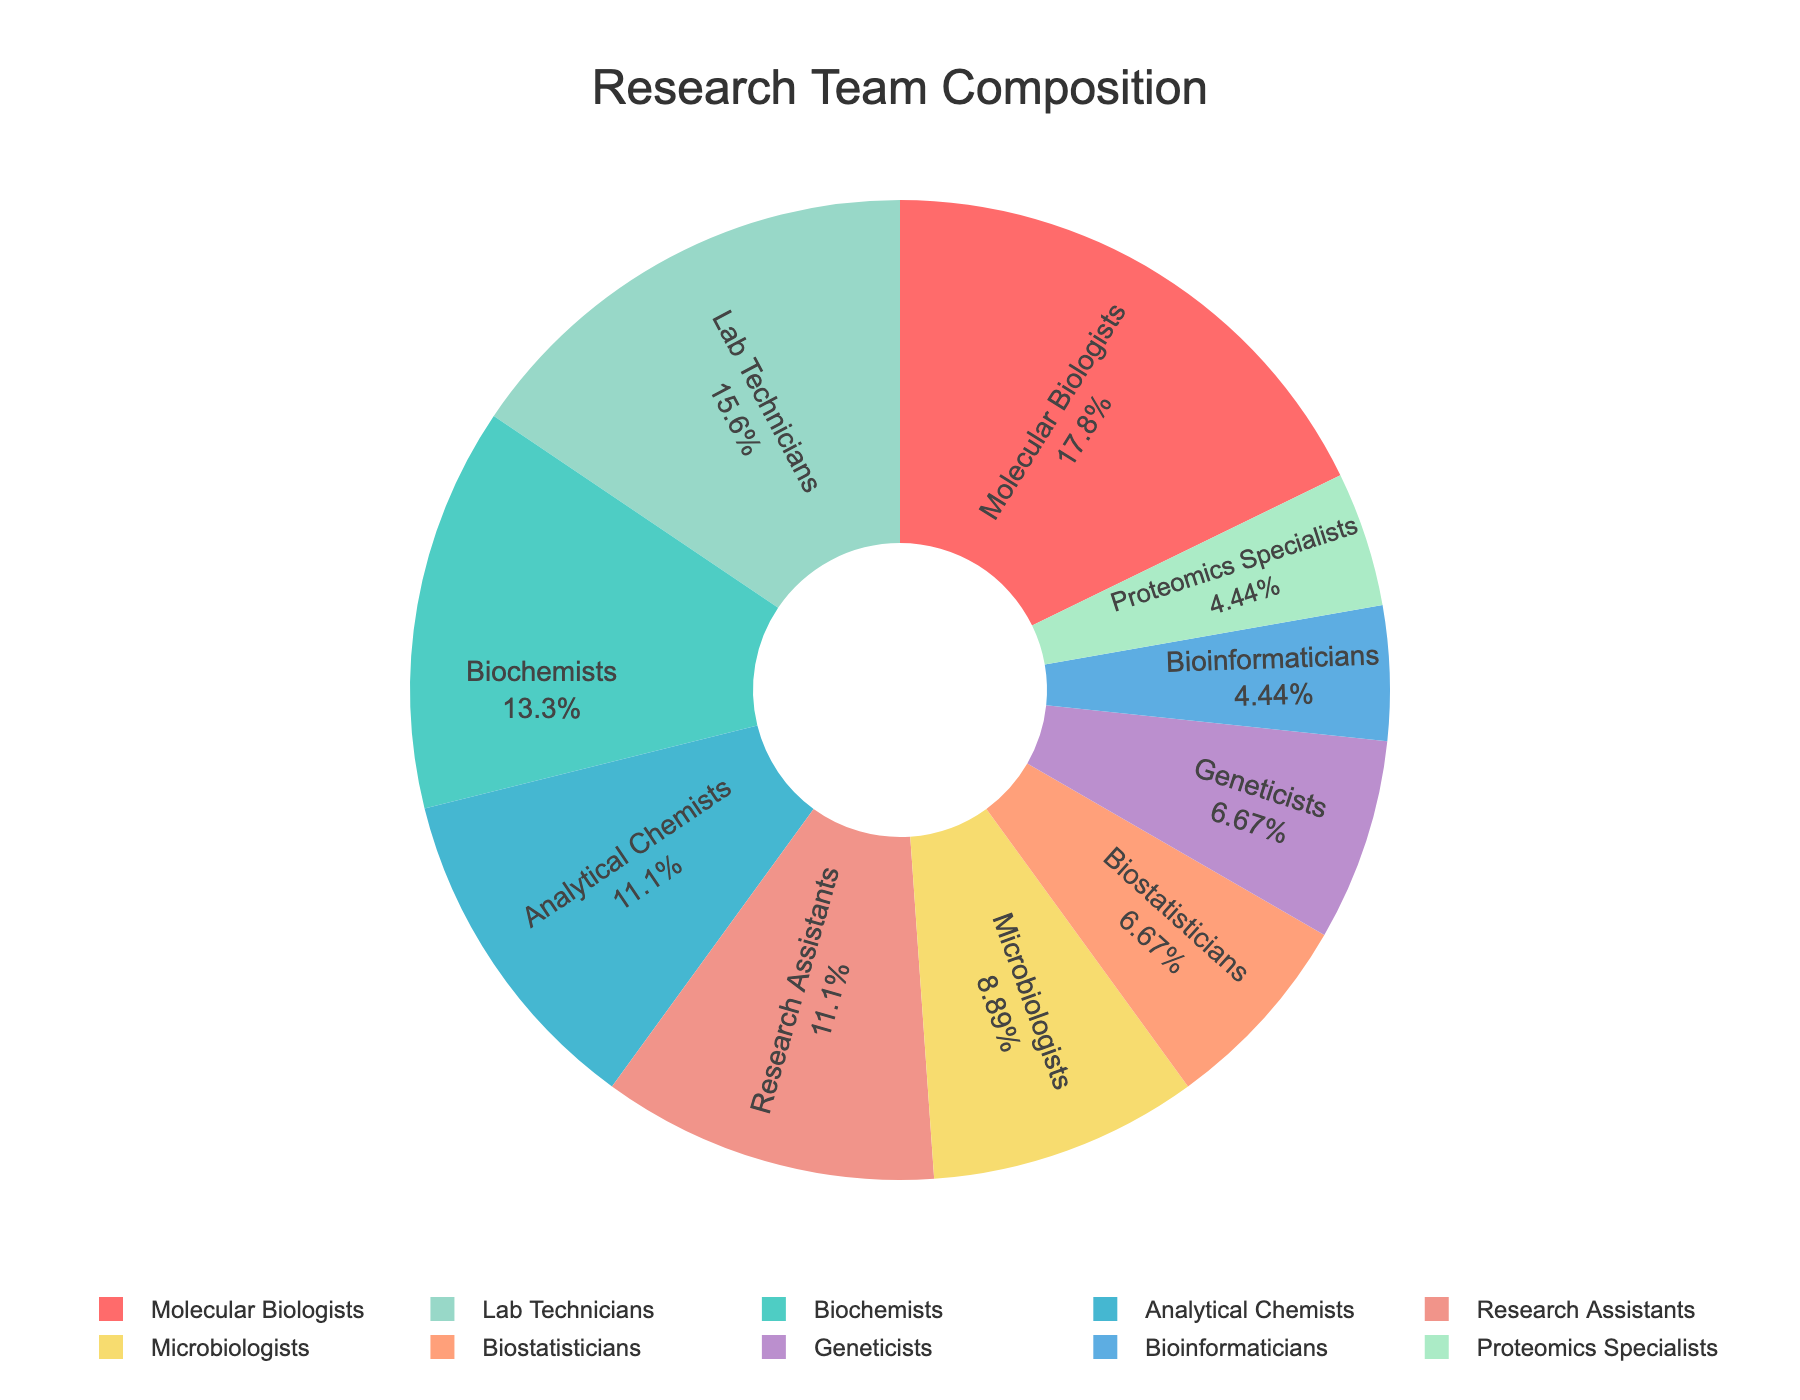What is the percentage of Molecular Biologists in the research team? Look at the label for Molecular Biologists on the pie chart; observe the percentage displayed inside the pie slice.
Answer: 22.9% How many more Lab Technicians are there compared to Geneticists? Locate the numbers for Lab Technicians and Geneticists on the pie chart. Subtract the number of Geneticists (3) from the number of Lab Technicians (7). 7 - 3 = 4.
Answer: 4 Which specialization has the smallest representation in the team? Look at the smallest slice on the pie chart and identify the label for that specialization.
Answer: Bioinformaticians and Proteomics Specialists What is the total number of Biostatisticians and Analytical Chemists combined? Add the number of Biostatisticians (3) and Analytical Chemists (5). 3 + 5 = 8.
Answer: 8 Which specialization has a representation closest to that of Microbiologists? Compare the slice sizes and percentages for each specialization to find the one closest to the 4 representatives of Microbiologists.
Answer: Research Assistants What is the combined percentage of Geneticists and Proteomics Specialists in the research team? Locate the percentages for Geneticists and Proteomics Specialists and add them together.
Answer: 11.4% Are there more Biochemists or Research Assistants, and by how many? Compare the numbers of Biochemists (6) and Research Assistants (5). Subtract the smaller number from the larger one. 6 - 5 = 1.
Answer: Biochemists by 1 If you added two more Biostatisticians to the team, what would their new percentage be? First, find the current total team members (8+6+5+3+7+4+3+2+5+2 = 45). Add the two new Biostatisticians to get 45 + 2 = 47 members. The new Biostatistician count is 3 + 2 = 5. Calculate the new percentage: (5/47) * 100 ≈ 10.64%.
Answer: 10.64% What would be the new total number of members if 3 more Microbiologists were added? Add 3 to the current number of Microbiologists (4). 4 + 3 = 7. Then, add these new members to the total current members (45). 45 + 3 = 48.
Answer: 48 What is the difference in representation between the highest and lowest represented specializations? Identify the highest represented specialization (Molecular Biologists, 8) and the lowest (Bioinformaticians and Proteomics Specialists, 2 each). Subtract the smallest number from the largest. 8 - 2 = 6.
Answer: 6 